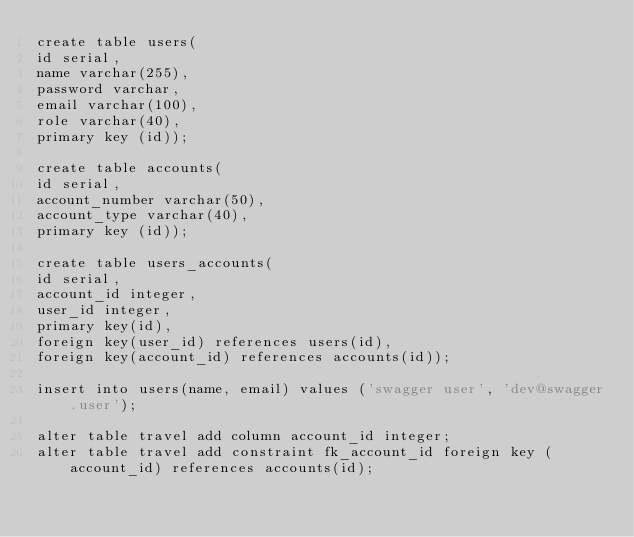<code> <loc_0><loc_0><loc_500><loc_500><_SQL_>create table users(
id serial,
name varchar(255),
password varchar,
email varchar(100),
role varchar(40),
primary key (id));

create table accounts(
id serial,
account_number varchar(50),
account_type varchar(40),
primary key (id));

create table users_accounts(
id serial,
account_id integer,
user_id integer,
primary key(id),
foreign key(user_id) references users(id),
foreign key(account_id) references accounts(id));

insert into users(name, email) values ('swagger user', 'dev@swagger.user');

alter table travel add column account_id integer;
alter table travel add constraint fk_account_id foreign key (account_id) references accounts(id);</code> 